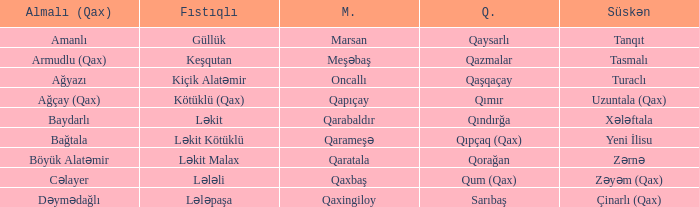What is the Almali village with the Süskən village zərnə? Böyük Alatəmir. 